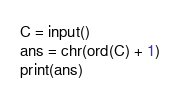<code> <loc_0><loc_0><loc_500><loc_500><_Python_>C = input()
ans = chr(ord(C) + 1)
print(ans)</code> 